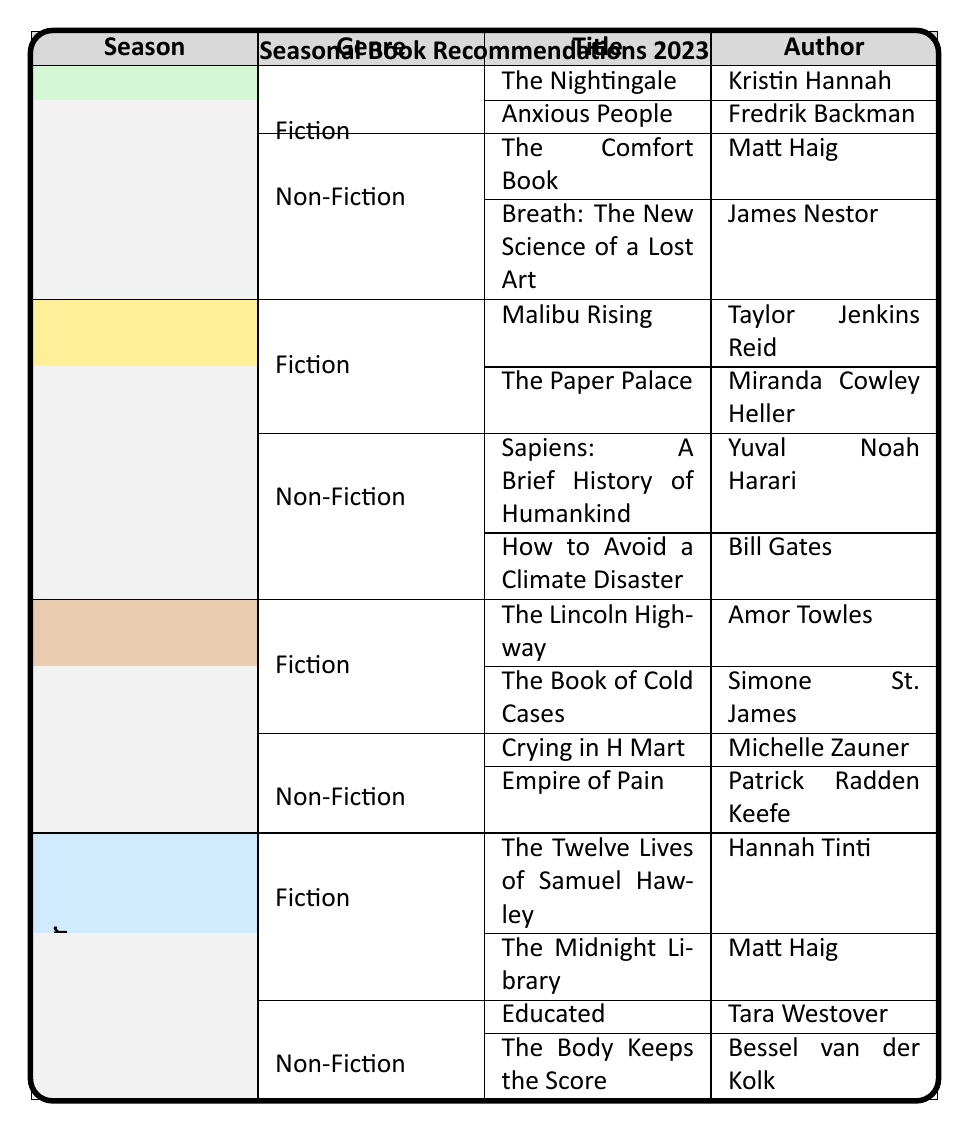What are two fiction book recommendations for Spring 2023? The table clearly lists the fiction books under the Spring season. The titles provided in the Fiction category for Spring are "The Nightingale" by Kristin Hannah and "Anxious People" by Fredrik Backman.
Answer: "The Nightingale" and "Anxious People" Which author wrote "Sapiens: A Brief History of Humankind"? By examining the Non-Fiction section for Summer, we see that "Sapiens: A Brief History of Humankind" is listed, and it is authored by Yuval Noah Harari.
Answer: Yuval Noah Harari Are there more fiction or non-fiction book recommendations for Fall 2023? The table shows that both Fiction and Non-Fiction categories for Fall have 2 book recommendations each. Therefore, they are equal in number.
Answer: No, they are equal How many total book recommendations are there for Winter 2023? For Winter, there are 4 book recommendations total: 2 in the Fiction category ("The Twelve Lives of Samuel Hawley" and "The Midnight Library") and 2 in the Non-Fiction category ("Educated" and "The Body Keeps the Score"). Adding these gives 4 books.
Answer: 4 Is "The Lincoln Highway" a recommendation for summer? By looking at the table, "The Lincoln Highway" is listed under the Fiction section for Fall 2023, not Summer. Thus, the statement is false.
Answer: No Which season has the most fiction book recommendations overall? The table indicates that each season has 2 fiction recommendations (Spring, Summer, Fall, Winter), so there is no distinct season with more fiction recommendations; they are all equal.
Answer: Each season has 2, so they are all equal 